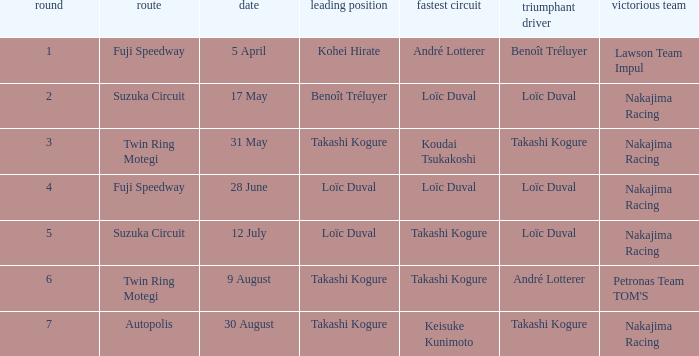How many drivers drove on Suzuka Circuit where Loïc Duval took pole position? 1.0. 